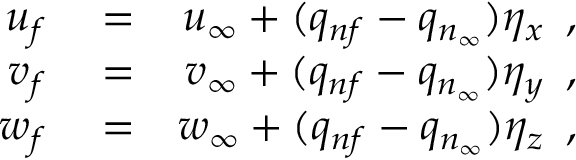Convert formula to latex. <formula><loc_0><loc_0><loc_500><loc_500>\begin{array} { r l r } { u _ { f } } & = } & { u _ { \infty } + ( q _ { n f } - q _ { n _ { \infty } } ) \eta _ { x } \, , } \\ { v _ { f } } & = } & { v _ { \infty } + ( q _ { n f } - q _ { n _ { \infty } } ) \eta _ { y } \, , } \\ { w _ { f } } & = } & { w _ { \infty } + ( q _ { n f } - q _ { n _ { \infty } } ) \eta _ { z } \, , } \end{array}</formula> 